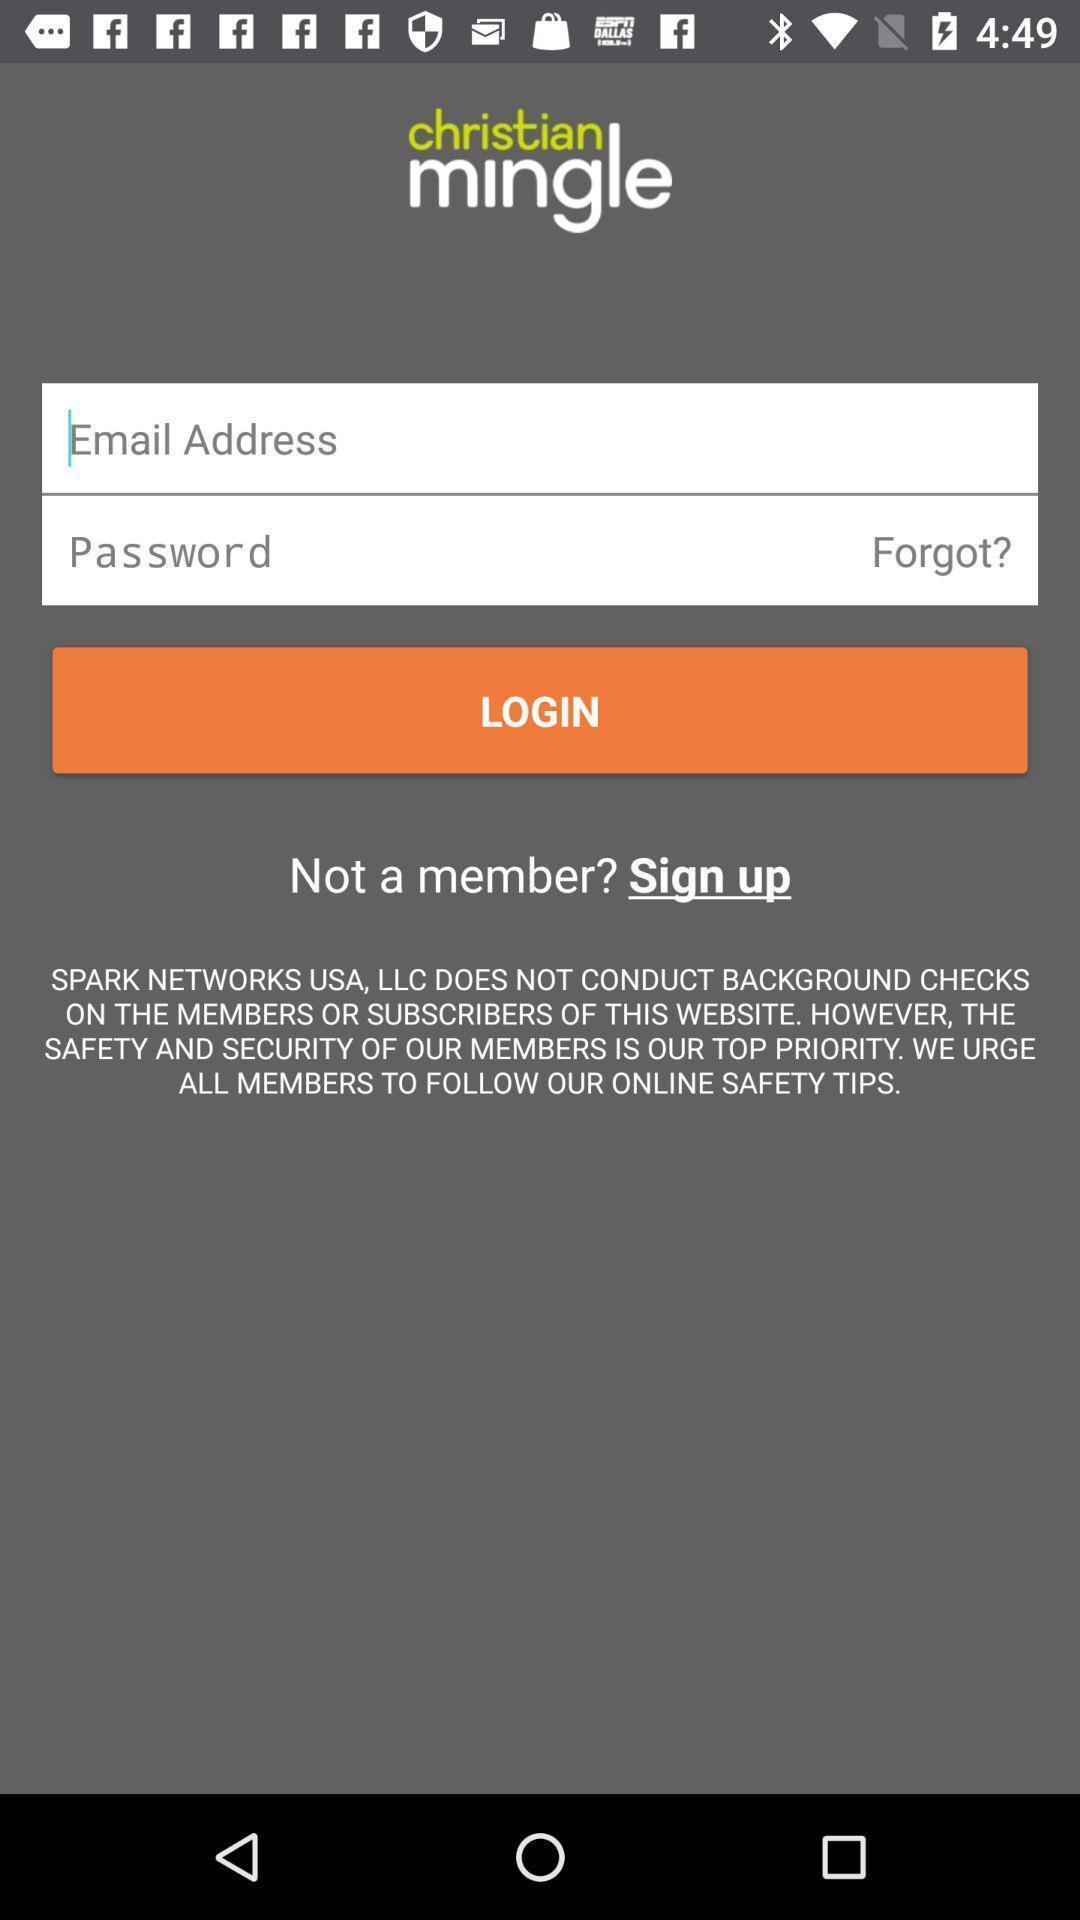Describe the visual elements of this screenshot. Login page of a dating app. 